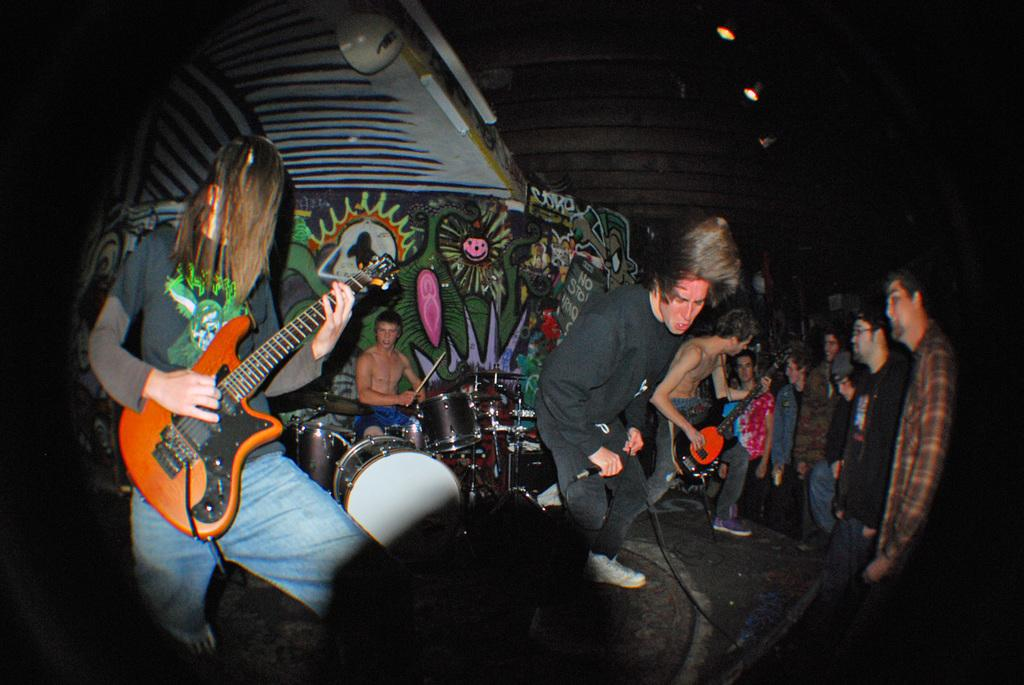Where was the image taken? The image was taken on a stage. What are the people in the image doing? The people are holding music instruments and singing a song. What can be seen behind the people in the image? There is a wall behind the people in the image. What type of destruction can be seen happening to the bushes in the image? There are no bushes present in the image, so no destruction can be observed. What word is being emphasized by the people in the song they are singing? The image does not provide information about the specific lyrics or words being emphasized in the song. 